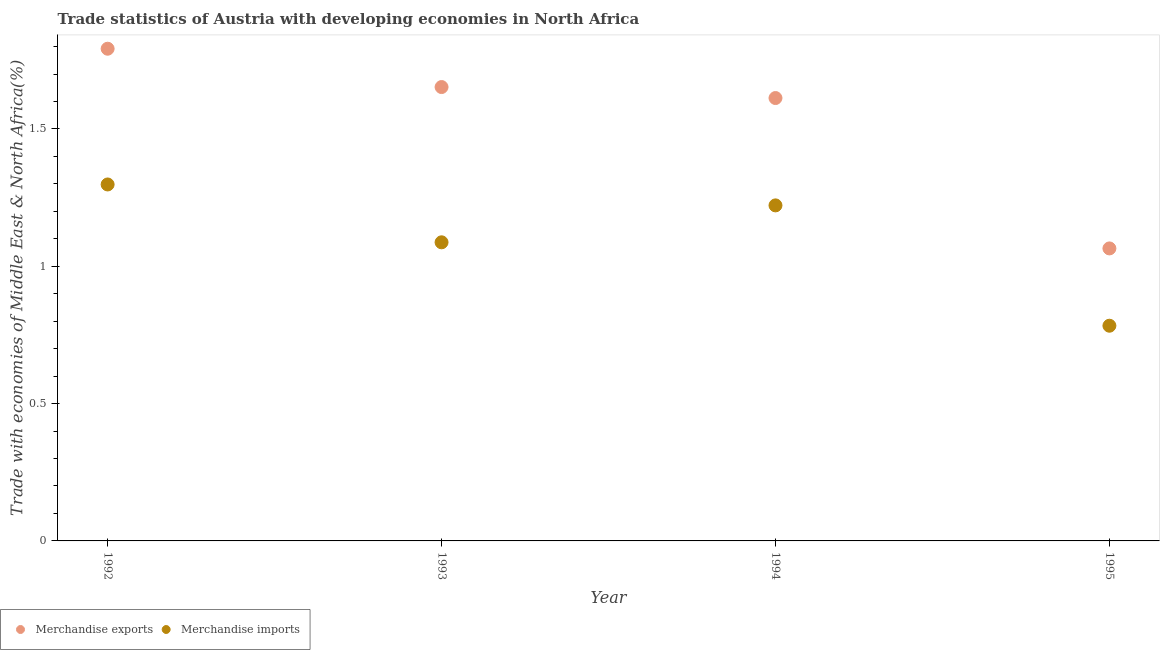What is the merchandise exports in 1995?
Keep it short and to the point. 1.07. Across all years, what is the maximum merchandise imports?
Give a very brief answer. 1.3. Across all years, what is the minimum merchandise exports?
Provide a short and direct response. 1.07. What is the total merchandise imports in the graph?
Your answer should be compact. 4.39. What is the difference between the merchandise imports in 1994 and that in 1995?
Keep it short and to the point. 0.44. What is the difference between the merchandise imports in 1994 and the merchandise exports in 1993?
Your answer should be very brief. -0.43. What is the average merchandise exports per year?
Provide a short and direct response. 1.53. In the year 1995, what is the difference between the merchandise imports and merchandise exports?
Give a very brief answer. -0.28. What is the ratio of the merchandise exports in 1992 to that in 1993?
Give a very brief answer. 1.08. What is the difference between the highest and the second highest merchandise exports?
Your answer should be very brief. 0.14. What is the difference between the highest and the lowest merchandise exports?
Your answer should be compact. 0.73. Is the sum of the merchandise imports in 1992 and 1995 greater than the maximum merchandise exports across all years?
Make the answer very short. Yes. Does the merchandise exports monotonically increase over the years?
Make the answer very short. No. Is the merchandise imports strictly less than the merchandise exports over the years?
Ensure brevity in your answer.  Yes. How many dotlines are there?
Provide a short and direct response. 2. What is the difference between two consecutive major ticks on the Y-axis?
Make the answer very short. 0.5. Are the values on the major ticks of Y-axis written in scientific E-notation?
Provide a short and direct response. No. Does the graph contain grids?
Offer a terse response. No. How many legend labels are there?
Keep it short and to the point. 2. What is the title of the graph?
Keep it short and to the point. Trade statistics of Austria with developing economies in North Africa. Does "2012 US$" appear as one of the legend labels in the graph?
Offer a terse response. No. What is the label or title of the Y-axis?
Provide a succinct answer. Trade with economies of Middle East & North Africa(%). What is the Trade with economies of Middle East & North Africa(%) in Merchandise exports in 1992?
Provide a succinct answer. 1.79. What is the Trade with economies of Middle East & North Africa(%) of Merchandise imports in 1992?
Offer a very short reply. 1.3. What is the Trade with economies of Middle East & North Africa(%) of Merchandise exports in 1993?
Provide a short and direct response. 1.65. What is the Trade with economies of Middle East & North Africa(%) in Merchandise imports in 1993?
Your response must be concise. 1.09. What is the Trade with economies of Middle East & North Africa(%) of Merchandise exports in 1994?
Your answer should be compact. 1.61. What is the Trade with economies of Middle East & North Africa(%) in Merchandise imports in 1994?
Provide a succinct answer. 1.22. What is the Trade with economies of Middle East & North Africa(%) of Merchandise exports in 1995?
Your response must be concise. 1.07. What is the Trade with economies of Middle East & North Africa(%) of Merchandise imports in 1995?
Ensure brevity in your answer.  0.78. Across all years, what is the maximum Trade with economies of Middle East & North Africa(%) of Merchandise exports?
Keep it short and to the point. 1.79. Across all years, what is the maximum Trade with economies of Middle East & North Africa(%) of Merchandise imports?
Your answer should be compact. 1.3. Across all years, what is the minimum Trade with economies of Middle East & North Africa(%) in Merchandise exports?
Provide a succinct answer. 1.07. Across all years, what is the minimum Trade with economies of Middle East & North Africa(%) of Merchandise imports?
Make the answer very short. 0.78. What is the total Trade with economies of Middle East & North Africa(%) of Merchandise exports in the graph?
Your answer should be very brief. 6.12. What is the total Trade with economies of Middle East & North Africa(%) of Merchandise imports in the graph?
Your answer should be compact. 4.39. What is the difference between the Trade with economies of Middle East & North Africa(%) of Merchandise exports in 1992 and that in 1993?
Make the answer very short. 0.14. What is the difference between the Trade with economies of Middle East & North Africa(%) of Merchandise imports in 1992 and that in 1993?
Provide a short and direct response. 0.21. What is the difference between the Trade with economies of Middle East & North Africa(%) in Merchandise exports in 1992 and that in 1994?
Ensure brevity in your answer.  0.18. What is the difference between the Trade with economies of Middle East & North Africa(%) of Merchandise imports in 1992 and that in 1994?
Give a very brief answer. 0.08. What is the difference between the Trade with economies of Middle East & North Africa(%) in Merchandise exports in 1992 and that in 1995?
Ensure brevity in your answer.  0.73. What is the difference between the Trade with economies of Middle East & North Africa(%) in Merchandise imports in 1992 and that in 1995?
Your answer should be very brief. 0.51. What is the difference between the Trade with economies of Middle East & North Africa(%) in Merchandise exports in 1993 and that in 1994?
Make the answer very short. 0.04. What is the difference between the Trade with economies of Middle East & North Africa(%) of Merchandise imports in 1993 and that in 1994?
Ensure brevity in your answer.  -0.13. What is the difference between the Trade with economies of Middle East & North Africa(%) in Merchandise exports in 1993 and that in 1995?
Offer a very short reply. 0.59. What is the difference between the Trade with economies of Middle East & North Africa(%) of Merchandise imports in 1993 and that in 1995?
Provide a succinct answer. 0.3. What is the difference between the Trade with economies of Middle East & North Africa(%) of Merchandise exports in 1994 and that in 1995?
Your answer should be very brief. 0.55. What is the difference between the Trade with economies of Middle East & North Africa(%) of Merchandise imports in 1994 and that in 1995?
Ensure brevity in your answer.  0.44. What is the difference between the Trade with economies of Middle East & North Africa(%) of Merchandise exports in 1992 and the Trade with economies of Middle East & North Africa(%) of Merchandise imports in 1993?
Give a very brief answer. 0.7. What is the difference between the Trade with economies of Middle East & North Africa(%) of Merchandise exports in 1992 and the Trade with economies of Middle East & North Africa(%) of Merchandise imports in 1994?
Your answer should be compact. 0.57. What is the difference between the Trade with economies of Middle East & North Africa(%) of Merchandise exports in 1992 and the Trade with economies of Middle East & North Africa(%) of Merchandise imports in 1995?
Ensure brevity in your answer.  1.01. What is the difference between the Trade with economies of Middle East & North Africa(%) in Merchandise exports in 1993 and the Trade with economies of Middle East & North Africa(%) in Merchandise imports in 1994?
Your answer should be very brief. 0.43. What is the difference between the Trade with economies of Middle East & North Africa(%) of Merchandise exports in 1993 and the Trade with economies of Middle East & North Africa(%) of Merchandise imports in 1995?
Provide a short and direct response. 0.87. What is the difference between the Trade with economies of Middle East & North Africa(%) of Merchandise exports in 1994 and the Trade with economies of Middle East & North Africa(%) of Merchandise imports in 1995?
Provide a short and direct response. 0.83. What is the average Trade with economies of Middle East & North Africa(%) of Merchandise exports per year?
Offer a very short reply. 1.53. What is the average Trade with economies of Middle East & North Africa(%) in Merchandise imports per year?
Your answer should be compact. 1.1. In the year 1992, what is the difference between the Trade with economies of Middle East & North Africa(%) of Merchandise exports and Trade with economies of Middle East & North Africa(%) of Merchandise imports?
Ensure brevity in your answer.  0.49. In the year 1993, what is the difference between the Trade with economies of Middle East & North Africa(%) in Merchandise exports and Trade with economies of Middle East & North Africa(%) in Merchandise imports?
Give a very brief answer. 0.57. In the year 1994, what is the difference between the Trade with economies of Middle East & North Africa(%) in Merchandise exports and Trade with economies of Middle East & North Africa(%) in Merchandise imports?
Your response must be concise. 0.39. In the year 1995, what is the difference between the Trade with economies of Middle East & North Africa(%) in Merchandise exports and Trade with economies of Middle East & North Africa(%) in Merchandise imports?
Ensure brevity in your answer.  0.28. What is the ratio of the Trade with economies of Middle East & North Africa(%) of Merchandise exports in 1992 to that in 1993?
Keep it short and to the point. 1.08. What is the ratio of the Trade with economies of Middle East & North Africa(%) of Merchandise imports in 1992 to that in 1993?
Provide a short and direct response. 1.19. What is the ratio of the Trade with economies of Middle East & North Africa(%) in Merchandise exports in 1992 to that in 1994?
Keep it short and to the point. 1.11. What is the ratio of the Trade with economies of Middle East & North Africa(%) of Merchandise imports in 1992 to that in 1994?
Your answer should be compact. 1.06. What is the ratio of the Trade with economies of Middle East & North Africa(%) in Merchandise exports in 1992 to that in 1995?
Provide a short and direct response. 1.68. What is the ratio of the Trade with economies of Middle East & North Africa(%) of Merchandise imports in 1992 to that in 1995?
Your answer should be compact. 1.66. What is the ratio of the Trade with economies of Middle East & North Africa(%) in Merchandise exports in 1993 to that in 1994?
Make the answer very short. 1.02. What is the ratio of the Trade with economies of Middle East & North Africa(%) in Merchandise imports in 1993 to that in 1994?
Your response must be concise. 0.89. What is the ratio of the Trade with economies of Middle East & North Africa(%) in Merchandise exports in 1993 to that in 1995?
Make the answer very short. 1.55. What is the ratio of the Trade with economies of Middle East & North Africa(%) in Merchandise imports in 1993 to that in 1995?
Provide a succinct answer. 1.39. What is the ratio of the Trade with economies of Middle East & North Africa(%) in Merchandise exports in 1994 to that in 1995?
Keep it short and to the point. 1.51. What is the ratio of the Trade with economies of Middle East & North Africa(%) of Merchandise imports in 1994 to that in 1995?
Give a very brief answer. 1.56. What is the difference between the highest and the second highest Trade with economies of Middle East & North Africa(%) in Merchandise exports?
Make the answer very short. 0.14. What is the difference between the highest and the second highest Trade with economies of Middle East & North Africa(%) of Merchandise imports?
Offer a very short reply. 0.08. What is the difference between the highest and the lowest Trade with economies of Middle East & North Africa(%) of Merchandise exports?
Make the answer very short. 0.73. What is the difference between the highest and the lowest Trade with economies of Middle East & North Africa(%) in Merchandise imports?
Offer a terse response. 0.51. 